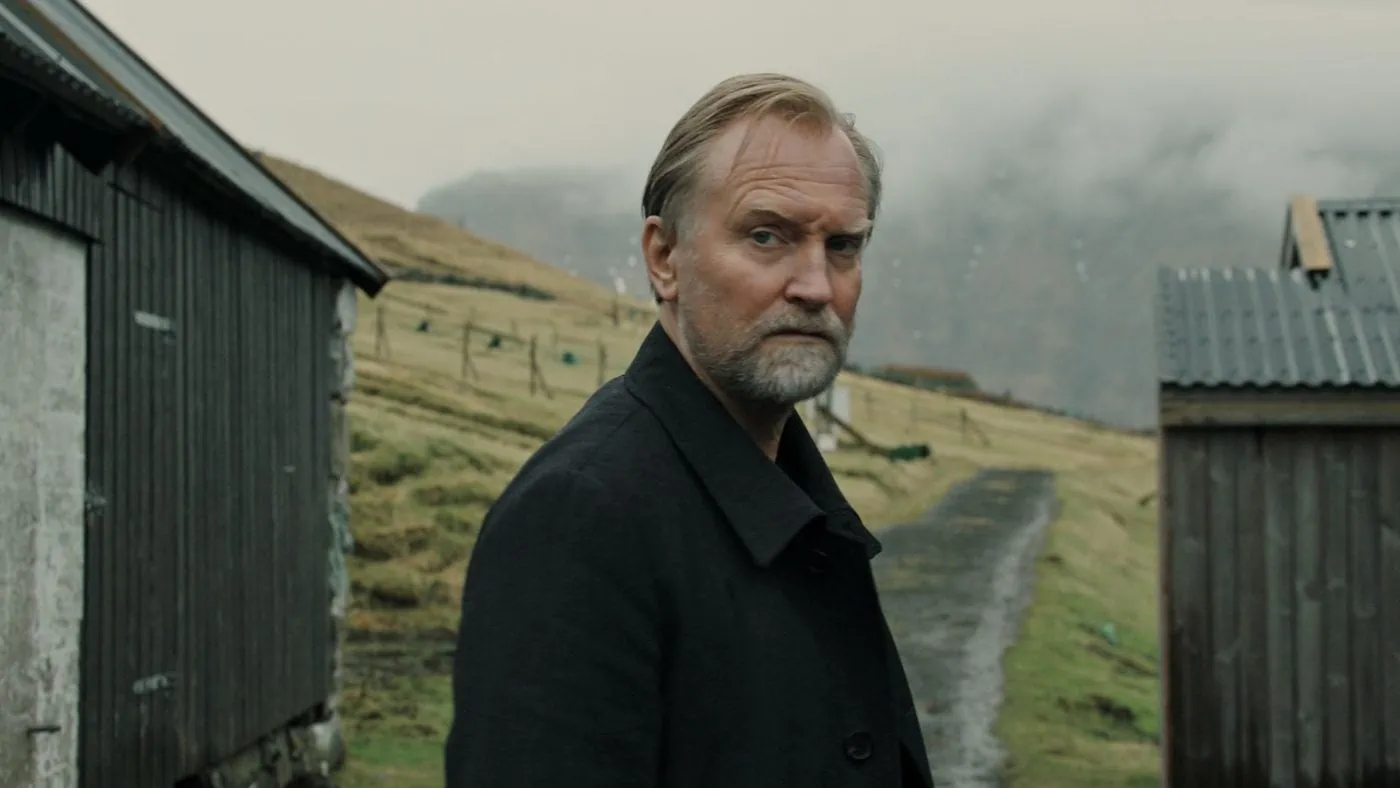Can you describe this image in more detail? This image portrays a middle-aged man with a contemplative demeanor, standing in a picturesque rural setting. He is wearing a sleek, dark coat that stands out against the muted, earthy colors of the landscape. The background features a grassy hill bordered by a wooden fence and two weathered sheds, which add a touch of rustic charm. The cloudy sky above lends a soft, diffused light, accentuating the reflective mood of the scene. His expression, a mixture of introspection and pensiveness, suggests he might be lost in thought about something profound or significant. 